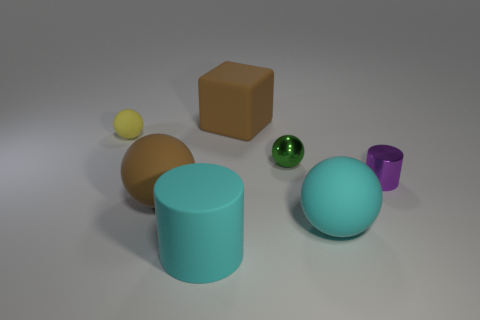Add 1 big cyan cylinders. How many objects exist? 8 Subtract all spheres. How many objects are left? 3 Subtract all big blue matte cylinders. Subtract all yellow rubber spheres. How many objects are left? 6 Add 1 purple cylinders. How many purple cylinders are left? 2 Add 4 brown balls. How many brown balls exist? 5 Subtract 0 brown cylinders. How many objects are left? 7 